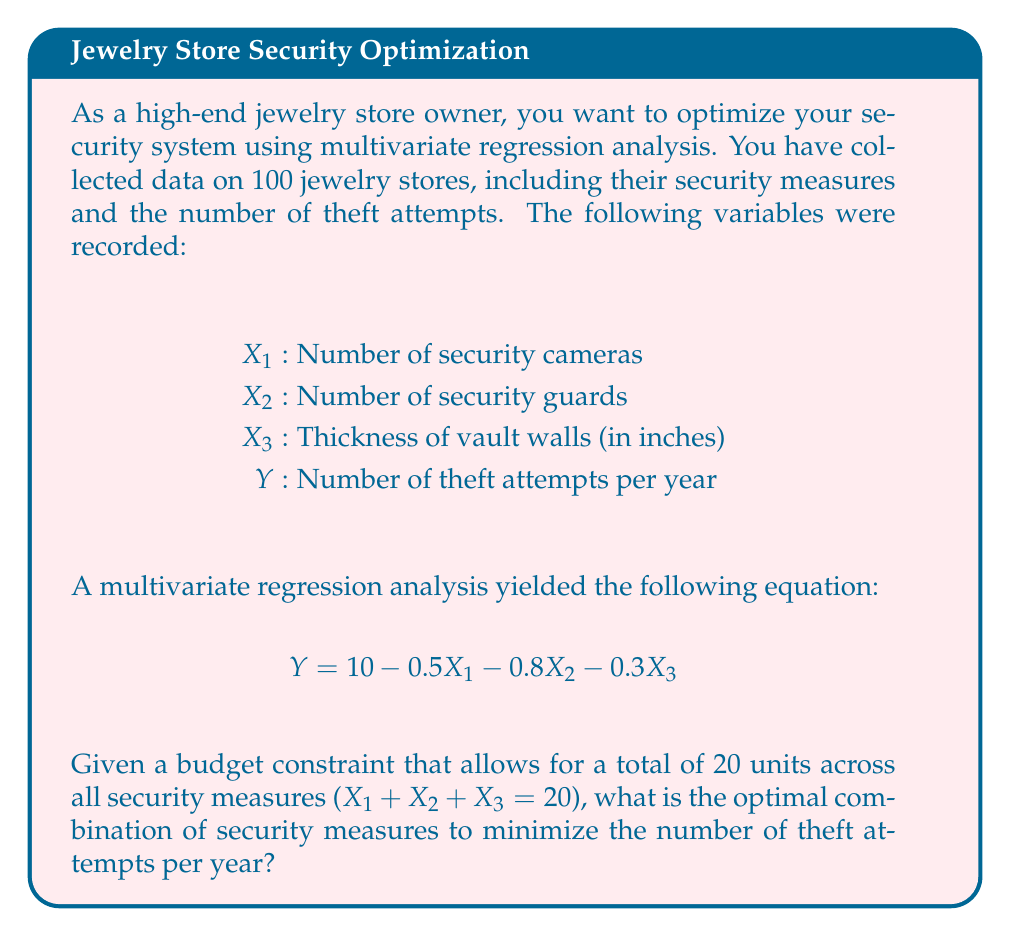Show me your answer to this math problem. To solve this optimization problem, we need to use the method of Lagrange multipliers, as we have a constraint on our variables.

Step 1: Set up the Lagrangian function
$$L(X_1, X_2, X_3, \lambda) = Y + \lambda(X_1 + X_2 + X_3 - 20)$$
$$L(X_1, X_2, X_3, \lambda) = (10 - 0.5X_1 - 0.8X_2 - 0.3X_3) + \lambda(X_1 + X_2 + X_3 - 20)$$

Step 2: Take partial derivatives and set them equal to zero
$$\frac{\partial L}{\partial X_1} = -0.5 + \lambda = 0$$
$$\frac{\partial L}{\partial X_2} = -0.8 + \lambda = 0$$
$$\frac{\partial L}{\partial X_3} = -0.3 + \lambda = 0$$
$$\frac{\partial L}{\partial \lambda} = X_1 + X_2 + X_3 - 20 = 0$$

Step 3: Solve the system of equations
From the first three equations, we can see that:
$$\lambda = 0.5 = 0.8 = 0.3$$

This is impossible unless $X_1 = X_2 = 0$ and all resources are allocated to $X_3$. However, this doesn't satisfy our constraint.

Instead, we should allocate resources to the variable with the highest coefficient (absolute value) in the regression equation, which is $X_2$ (security guards).

Step 4: Determine the optimal allocation
Allocate as much as possible to $X_2$, then to $X_1$, and finally to $X_3$:
$X_2 = 20$ (security guards)
$X_1 = 0$ (security cameras)
$X_3 = 0$ (vault wall thickness)

Step 5: Calculate the minimum number of theft attempts
$$Y = 10 - 0.5(0) - 0.8(20) - 0.3(0) = 10 - 16 = -6$$

Since we can't have negative theft attempts, we round up to 0.
Answer: Optimal configuration: 20 security guards, 0 cameras, 0 inches of extra vault thickness. Minimum theft attempts: 0 per year. 